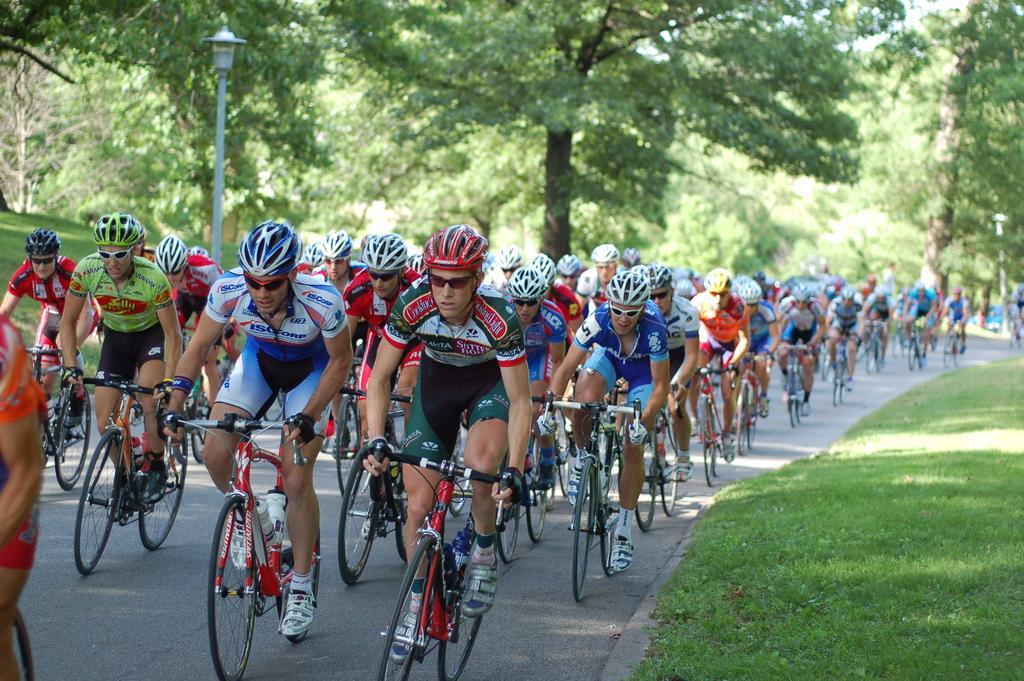Can you describe this image briefly? At the center of the image there are people cycling on the road. On both right and left side of the image there is grass on the surface. In the background of the image there are trees and street lights. 